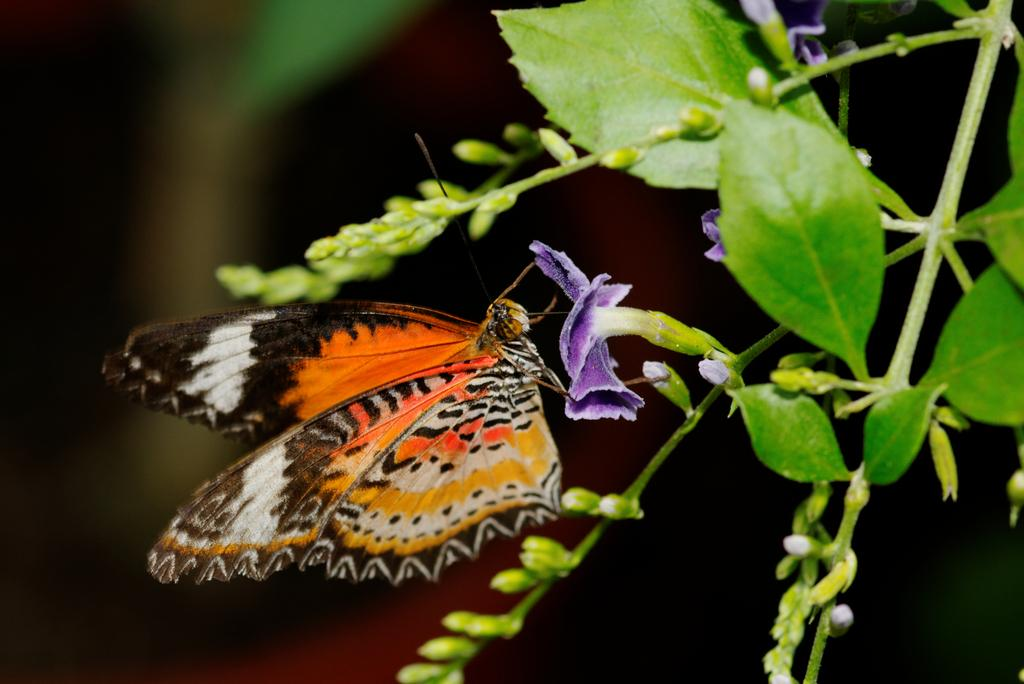What type of living organism can be seen in the image? There is a plant in the image, and there are flowers on the plant. Can you describe any other living organisms in the image? Yes, there is a butterfly on one of the flowers. What is the color of the background in the image? The background of the image is dark. How many sheep can be seen grazing in the image? There are no sheep present in the image. What is the butterfly's desire while it is on the flower? There is no information about the butterfly's desires in the image. 